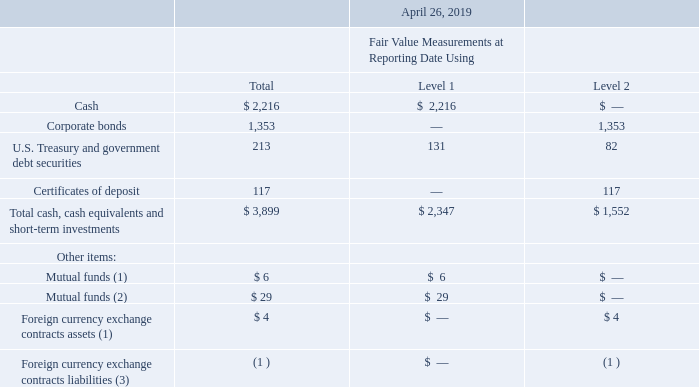Fair Value of Financial Instruments
The following table summarizes our financial assets and liabilities measured at fair value on a recurring basis (in millions):
(1) Reported as other current assets in the consolidated balance sheets
(2) Reported as other non-current assets in the consolidated balance sheets
(3) Reported as accrued expenses in the consolidated balance sheets
What does the table show? Summarizes our financial assets and liabilities measured at fair value on a recurring basis. What was the fair value measurements using Level 2 for Corporate Bonds?
Answer scale should be: million. 1,353. What were the total cash, cash equivalents and short-term investments?
Answer scale should be: million. 3,899. What was the difference in the fair value for U.S. Treasury and government debt securities between Level 1 and Level 2?
Answer scale should be: million. 131-82
Answer: 49. What was the fair value of Level 2 Total cash, cash equivalents and short-term investments as a percentage of the total cash, cash equivalents and short-term investments?
Answer scale should be: percent. 1,552/3,899
Answer: 39.81. What was the difference between the Total cash, cash equivalents and short-term investments for Level 1 and Level 2?
Answer scale should be: million. 2,347-1,552
Answer: 795. 